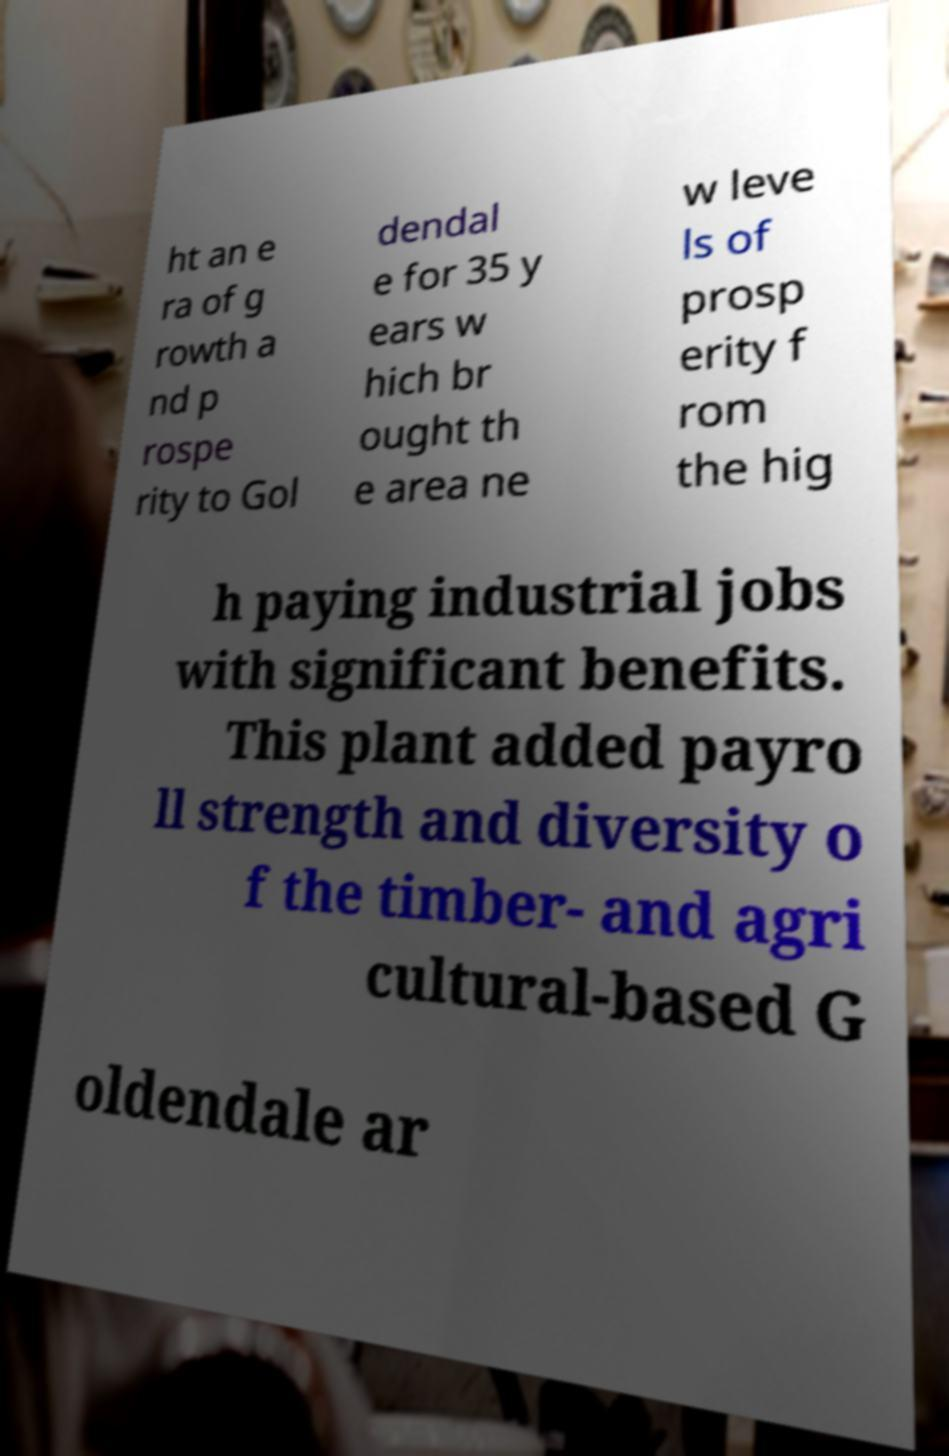Could you assist in decoding the text presented in this image and type it out clearly? ht an e ra of g rowth a nd p rospe rity to Gol dendal e for 35 y ears w hich br ought th e area ne w leve ls of prosp erity f rom the hig h paying industrial jobs with significant benefits. This plant added payro ll strength and diversity o f the timber- and agri cultural-based G oldendale ar 